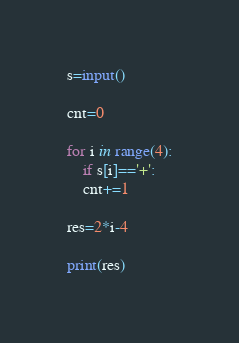<code> <loc_0><loc_0><loc_500><loc_500><_Python_>s=input()

cnt=0

for i in range(4):
	if s[i]=='+':
	cnt+=1

res=2*i-4

print(res)</code> 